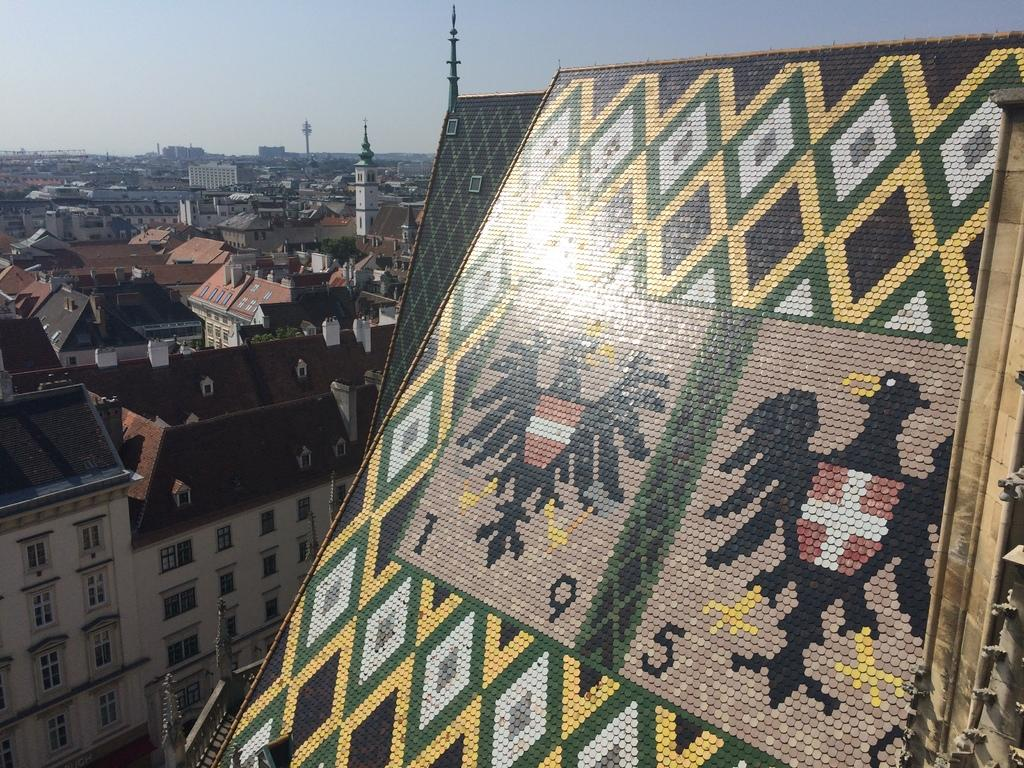What can be seen on the right side of the image? There is a roof with designs on the right side of the image. What is located on the left side of the image? There are buildings and towers on the left side of the image. What features can be observed on the buildings and towers? There are windows and a railing on the left side of the image. What is visible in the background of the image? The sky is visible in the image. What type of baby can be heard singing in the image? There is no baby or singing present in the image; it features a roof with designs, buildings, towers, windows, a railing, and the sky. What is the texture of the roof in the image? The provided facts do not mention the texture of the roof, so it cannot be determined from the image. 